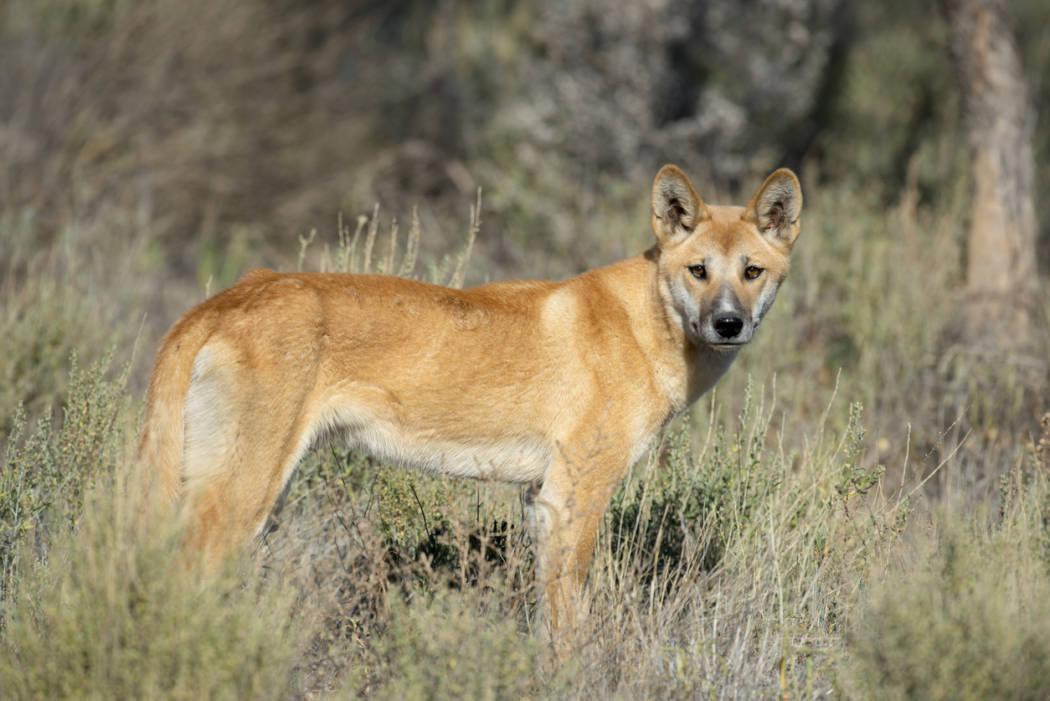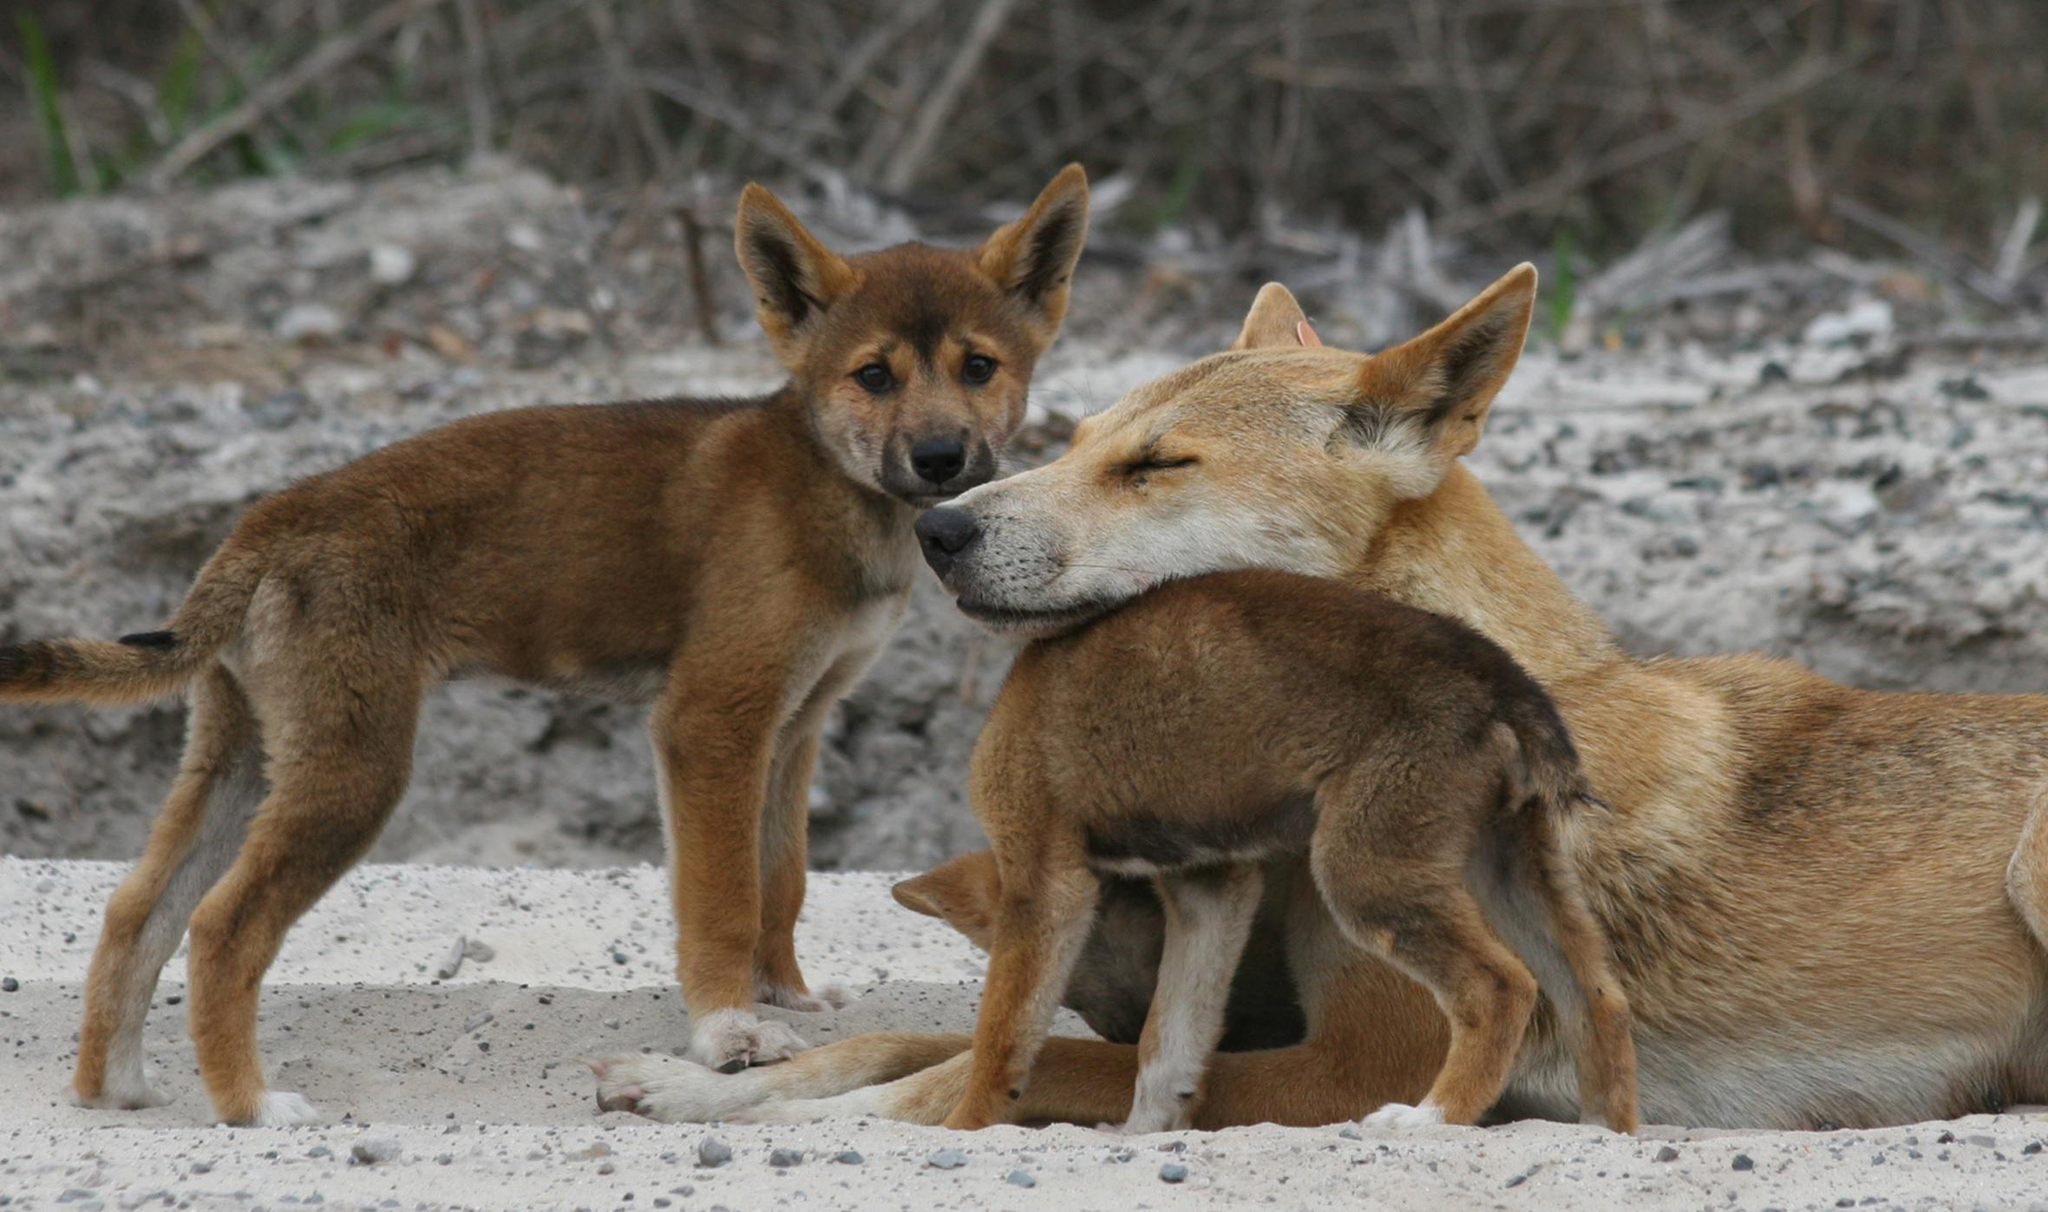The first image is the image on the left, the second image is the image on the right. For the images displayed, is the sentence "The left image contains twice the number of dogs as the right image, and at least two dogs in total are standing." factually correct? Answer yes or no. No. The first image is the image on the left, the second image is the image on the right. Analyze the images presented: Is the assertion "The left image contains exactly two wild dogs." valid? Answer yes or no. No. 